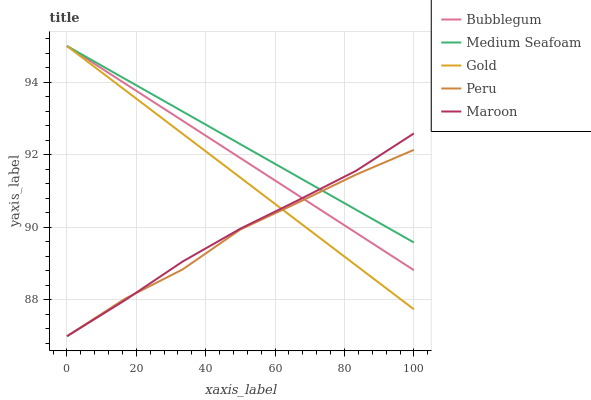Does Gold have the minimum area under the curve?
Answer yes or no. No. Does Gold have the maximum area under the curve?
Answer yes or no. No. Is Gold the smoothest?
Answer yes or no. No. Is Gold the roughest?
Answer yes or no. No. Does Gold have the lowest value?
Answer yes or no. No. Does Maroon have the highest value?
Answer yes or no. No. 